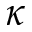Convert formula to latex. <formula><loc_0><loc_0><loc_500><loc_500>\kappa</formula> 